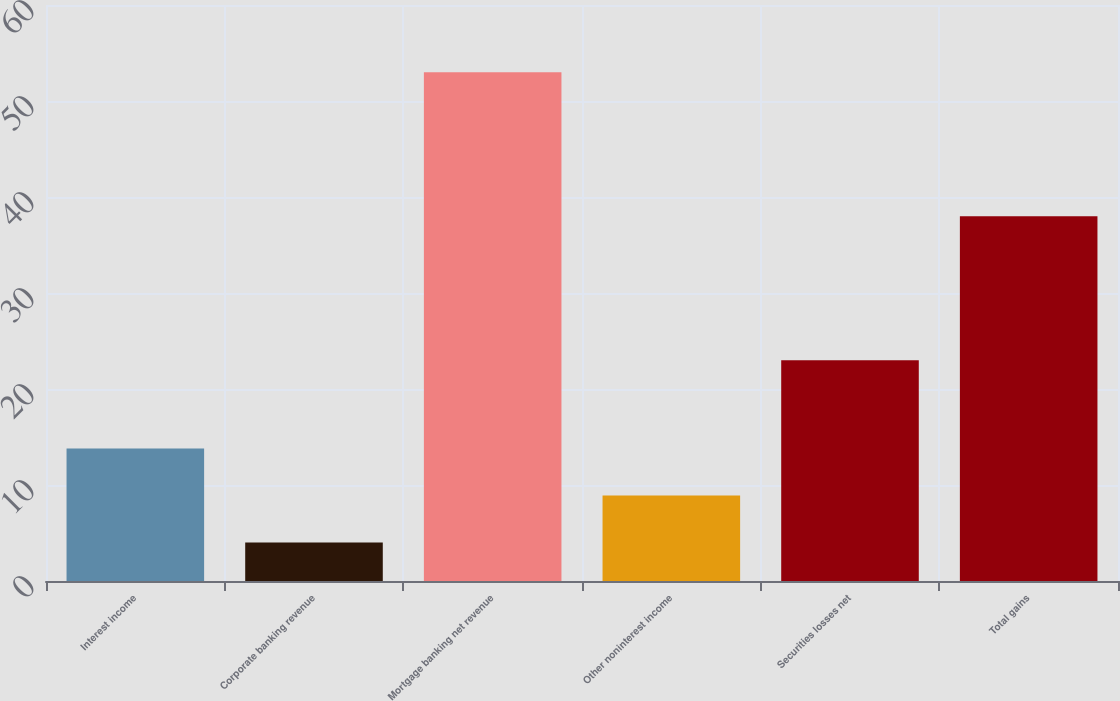Convert chart to OTSL. <chart><loc_0><loc_0><loc_500><loc_500><bar_chart><fcel>Interest income<fcel>Corporate banking revenue<fcel>Mortgage banking net revenue<fcel>Other noninterest income<fcel>Securities losses net<fcel>Total gains<nl><fcel>13.8<fcel>4<fcel>53<fcel>8.9<fcel>23<fcel>38<nl></chart> 